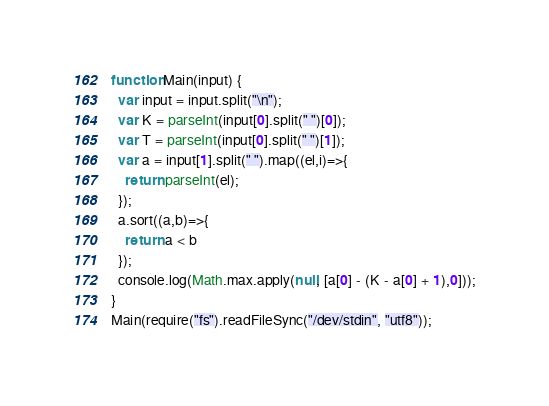<code> <loc_0><loc_0><loc_500><loc_500><_JavaScript_>function Main(input) {
  var input = input.split("\n");
  var K = parseInt(input[0].split(" ")[0]);
  var T = parseInt(input[0].split(" ")[1]);
  var a = input[1].split(" ").map((el,i)=>{
    return parseInt(el);
  });
  a.sort((a,b)=>{
    return a < b
  });
  console.log(Math.max.apply(null, [a[0] - (K - a[0] + 1),0]));
}
Main(require("fs").readFileSync("/dev/stdin", "utf8"));</code> 